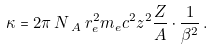<formula> <loc_0><loc_0><loc_500><loc_500>\kappa = 2 \pi \, N \, _ { A } \, r _ { e } ^ { 2 } m _ { e } c ^ { 2 } z ^ { 2 } \frac { Z } { A } \cdot \frac { 1 } { \beta ^ { 2 } } \, .</formula> 